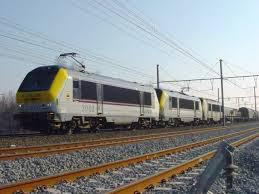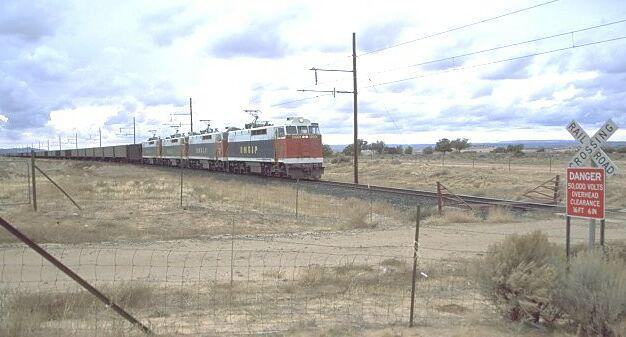The first image is the image on the left, the second image is the image on the right. For the images shown, is this caption "Multiple tracks are visible in the left image." true? Answer yes or no. Yes. 